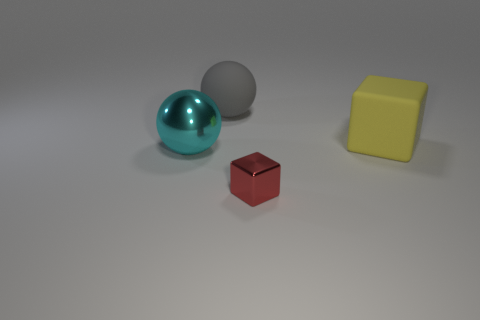Add 3 large matte spheres. How many objects exist? 7 Subtract all shiny spheres. Subtract all yellow cubes. How many objects are left? 2 Add 3 matte blocks. How many matte blocks are left? 4 Add 1 shiny balls. How many shiny balls exist? 2 Subtract 0 yellow cylinders. How many objects are left? 4 